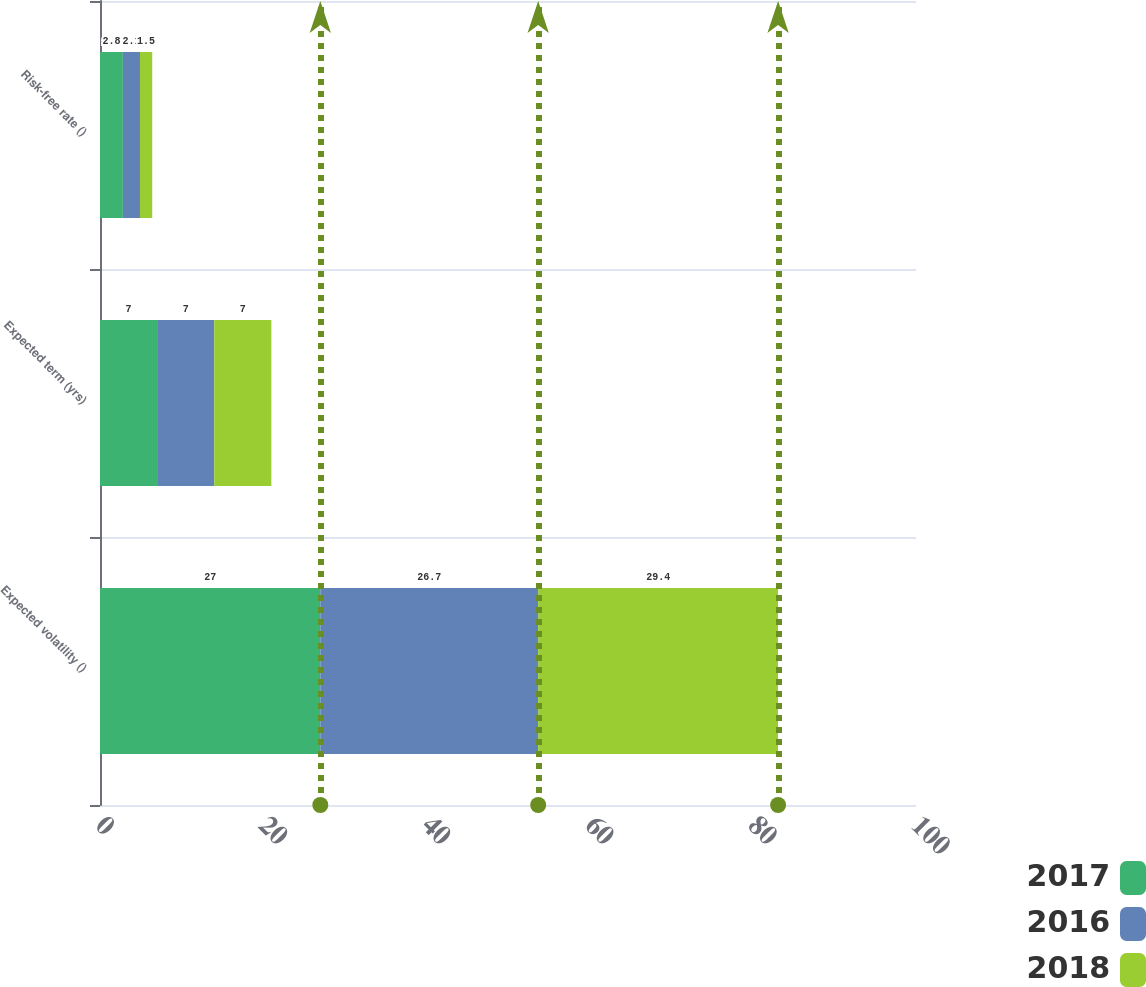Convert chart. <chart><loc_0><loc_0><loc_500><loc_500><stacked_bar_chart><ecel><fcel>Expected volatility ()<fcel>Expected term (yrs)<fcel>Risk-free rate ()<nl><fcel>2017<fcel>27<fcel>7<fcel>2.8<nl><fcel>2016<fcel>26.7<fcel>7<fcel>2.1<nl><fcel>2018<fcel>29.4<fcel>7<fcel>1.5<nl></chart> 